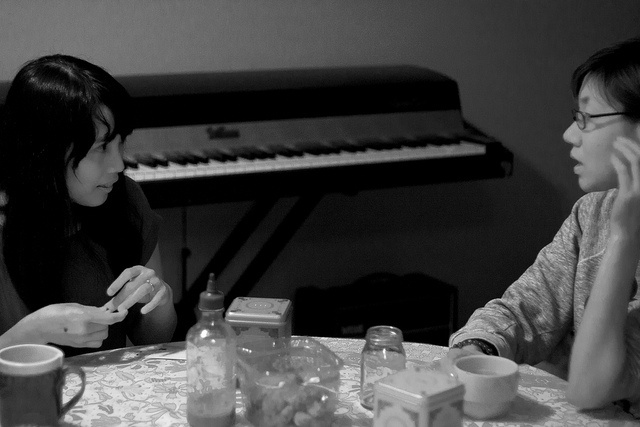Describe the objects in this image and their specific colors. I can see people in gray, black, darkgray, and lightgray tones, people in gray, black, and lightgray tones, dining table in gray, darkgray, lightgray, and black tones, cup in gray, black, darkgray, and lightgray tones, and bottle in gray, darkgray, lightgray, and black tones in this image. 